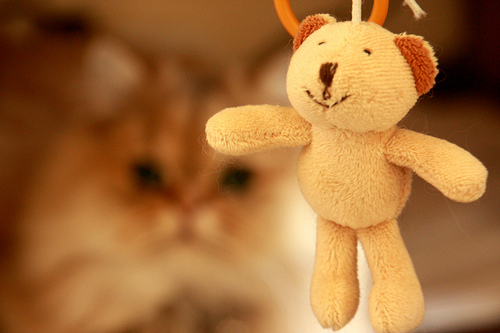<image>
Is there a cat in front of the bear? No. The cat is not in front of the bear. The spatial positioning shows a different relationship between these objects. 